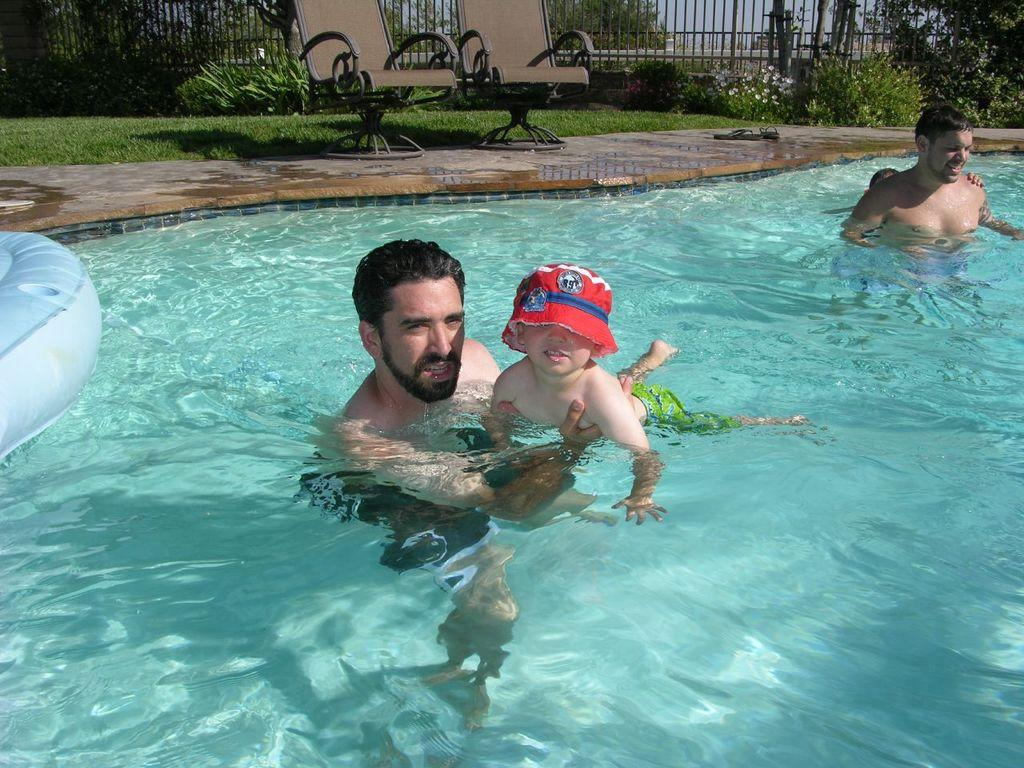What are the people and kids doing in the image? The people and kids are in the water. What can be seen at the top of the image? There is a grille, plants, chairs, and grass visible at the top of the image. What is floating above the water in the image? There is an inflatable tube above the water. What type of net can be seen catching the bears in the image? There are no bears or nets present in the image. How is the cream being used in the image? There is no cream present in the image. 